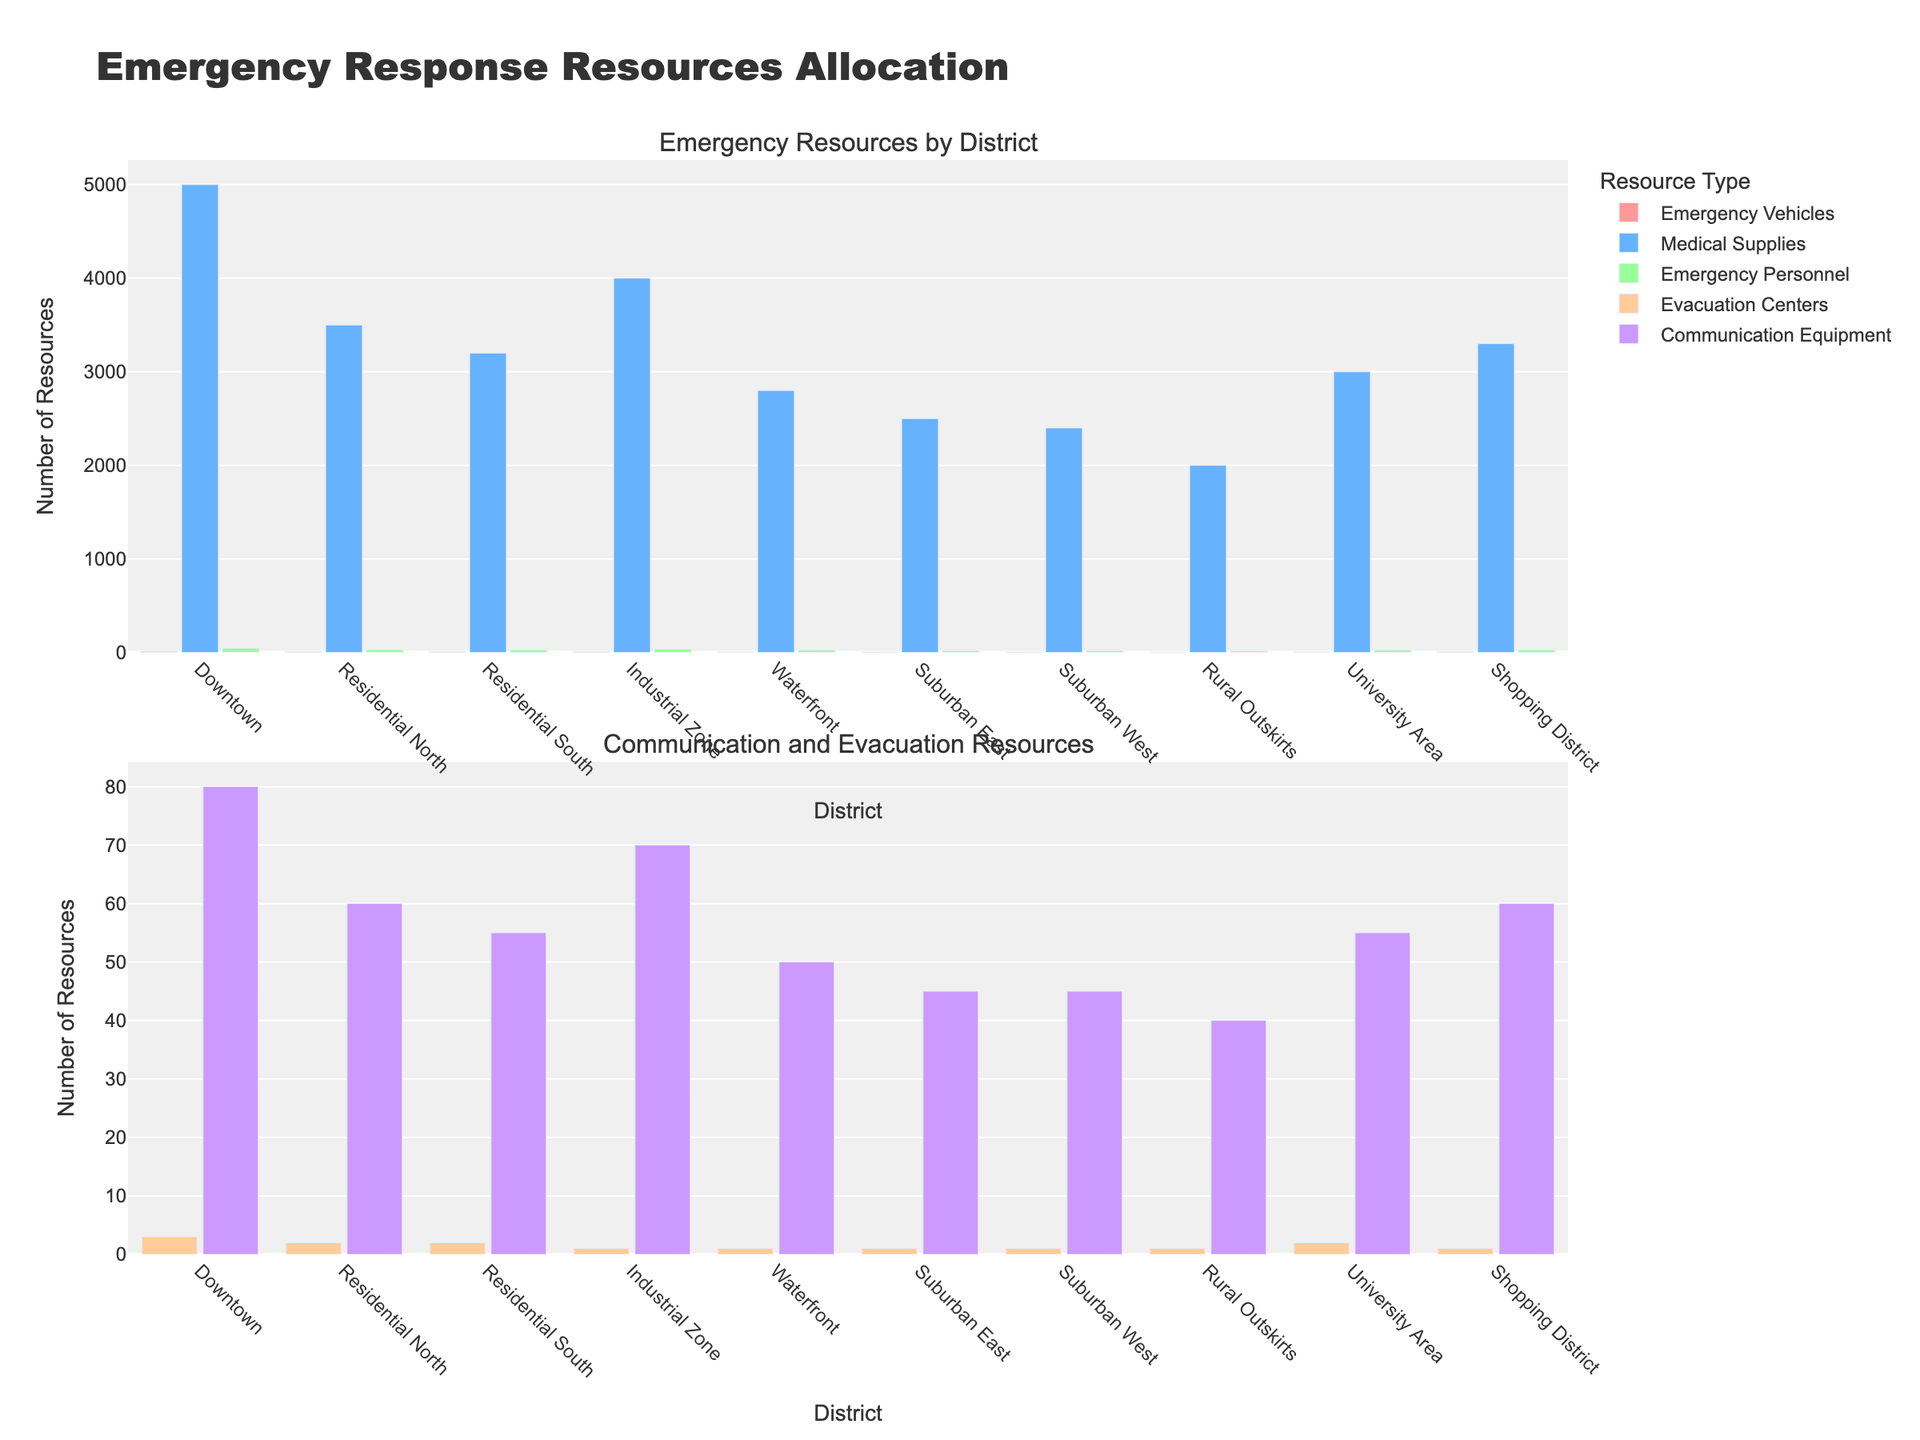Which district has the highest number of Emergency Vehicles? The highest red bar in the first subplot represents the District with the most Emergency Vehicles. From the figure, we see that Downtown has the tallest red bar representing Emergency Vehicles.
Answer: Downtown What is the total number of Emergency Personnel in Downtown and the Residential North? First, locate and sum the green bars for Emergency Personnel in both Downtown (45) and Residential North (30) from the first subplot. The total sum is 45 + 30 = 75.
Answer: 75 Which district has the least number of communication equipment units? Identify the shortest purple bar in the second subplot. The shortest purple bar represents the district with the least Communication Equipment units, which is Rural Outskirts with 40 units.
Answer: Rural Outskirts How many more Medical Supplies units does the Industrial Zone have compared to the Suburban East? Find the heights of the blue bars for both districts in the first subplot: Industrial Zone (4000 units) and Suburban East (2500 units). Subtract the smaller from the larger value: 4000 - 2500 = 1500.
Answer: 1500 Which district has the highest number of combined Evacuation Centers and Communication Equipment? For each district, add the heights of the yellow and purple bars from the second subplot. The Downtown has the highest combined total, with 3 Evacuation Centers and 80 Communication Equipment units; thus: 3 + 80 = 83.
Answer: Downtown What is the average number of Emergency Vehicles across all districts? Sum the number of Emergency Vehicles across all districts and divide by the number of districts. (12+8+7+10+6+5+5+4+6+7) / 10 = 70 / 10 = 7 vehicles.
Answer: 7 Which district has the least total amount of Medical Supplies and Emergency Personnel combined? Add the Medical Supplies units and Emergency Personnel for each district. The Rural Outskirts has the least amount combined with 2000 Medical Supplies and 15 Emergency Personnel, totalling 2015.
Answer: Rural Outskirts Which two districts have the same number of Evacuation Centers? Compare the yellow bars in the second subplot to find districts with the same value. The districts with the same number of Evacuation Centers (2 centers each) are Residential North and University Area.
Answer: Residential North and University Area Which district has a higher number of Emergency Vehicles, Residential South or Shopping District? Compare the heights of the red bars for Residential South (7) and Shopping District (7) in the first subplot; both are equal at 7.
Answer: Both have equal number What is the difference in the number of Emergency Personnel between the Industrial Zone and the Residential South? Find the green bar heights for Emergency Personnel in Industrial Zone (35) and Residential South (28) from the first subplot. Subtract to find the difference: 35 - 28 = 7.
Answer: 7 